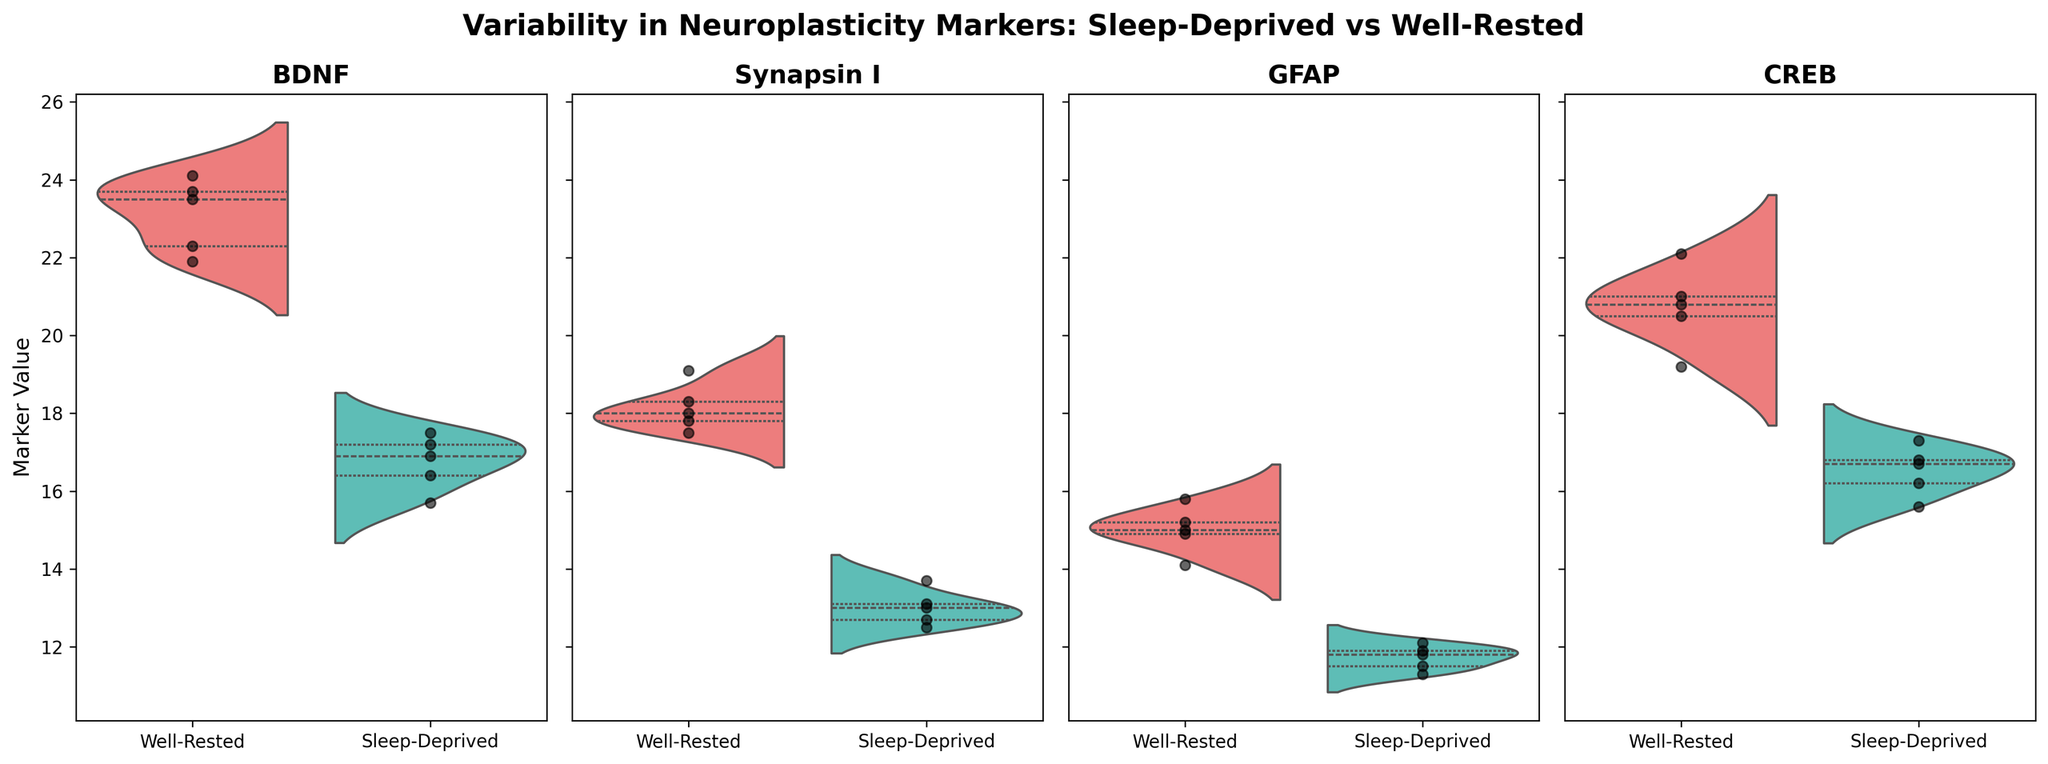What are the markers being compared in the figure? The figure compares four neuroplasticity markers. Each subplot has a title indicating one of the markers: BDNF, Synapsin I, GFAP, and CREB.
Answer: BDNF, Synapsin I, GFAP, CREB What is the title of the figure? The title of the figure is prominently displayed at the top and reads, "Variability in Neuroplasticity Markers: Sleep-Deprived vs Well-Rested."
Answer: Variability in Neuroplasticity Markers: Sleep-Deprived vs Well-Rested Which condition has the higher average value for the marker BDNF? For BDNF, the right side of the violin plot represents the well-rested condition, and the left side represents the sleep-deprived condition. The well-rested condition's distribution is centered around higher values (approximately 22-24) compared to the sleep-deprived condition's distribution (approximately 16-18).
Answer: Well-Rested How do the distributions of Synapsin I differ between sleep-deprived and well-rested subjects? For Synapsin I, the well-rested condition has a higher and broader distribution (centered around 17.5-19.1) while the sleep-deprived condition has a lower and narrower distribution (centered around 12.5-13.7).
Answer: The well-rested distribution is higher and broader What is the range of GFAP values for sleep-deprived subjects? The left side of the violin plot for GFAP (sleep-deprived condition) shows the distribution mostly lying between 11.3 and 12.1.
Answer: 11.3 to 12.1 Compare the median values of CREB for both conditions. The quartile markings inside the CREB violin plot indicate the medians for both conditions. The well-rested condition's median appears center-aligned in a higher range (~20.5-22.1), whereas the sleep-deprived condition's median is notably lower and falls around 15.6-17.3.
Answer: Well-Rested: ~ 21, Sleep-Deprived: ~ 17 Which marker shows the least difference in variability between the two conditions? Observing the violin plots, Synapsin I shows the least difference in variability, as both conditions have somewhat overlapping distributions, although centered differently.
Answer: Synapsin I How does sleep deprivation affect the variability in neuroplasticity markers based on the figure? The figure shows that sleep deprivation generally decreases the values and spreads of all markers. BDNF, Synapsin I, GFAP, and CREB, all have noticeably lower values and narrower distributions in the sleep-deprived condition.
Answer: Decreases values and spreads By looking at jittered points in the plot for BDNF, can we see any overlap for values between the two conditions? The scatter points on the BDNF plot indicate some individuals' values in the sleep-deprived condition overlap with the lower range of the well-rested condition values, particularly around values 17.5 to 18.
Answer: Yes, around 17.5 to 18 Considering the violin plot for CREB, which condition has more extreme values? Well-rested subjects have more extreme (higher) values observed in the distribution's tail at the right end of the plot for CREB, indicating they exhibit greater variability with some higher value outliers compared to sleep-deprived subjects.
Answer: Well-Rested 